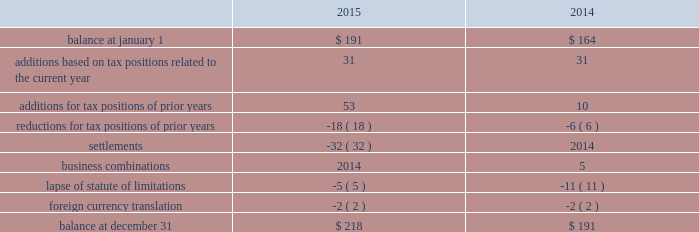Uncertain tax positions the following is a reconciliation of the company's beginning and ending amount of uncertain tax positions ( in millions ) : .
The company's liability for uncertain tax positions as of december 31 , 2015 , 2014 , and 2013 , includes $ 180 million , $ 154 million , and $ 141 million , respectively , related to amounts that would impact the effective tax rate if recognized .
It is possible that the amount of unrecognized tax benefits may change in the next twelve months ; however , we do not expect the change to have a significant impact on our consolidated statements of income or consolidated balance sheets .
These changes may be the result of settlements of ongoing audits .
At this time , an estimate of the range of the reasonably possible outcomes within the twelve months cannot be made .
The company recognizes interest and penalties related to uncertain tax positions in its provision for income taxes .
The company accrued potential interest and penalties of $ 2 million , $ 4 million , and $ 2 million in 2015 , 2014 , and 2013 , respectively .
The company recorded a liability for interest and penalties of $ 33 million , $ 31 million , and $ 27 million as of december 31 , 2015 , 2014 , and 2013 , respectively .
The company and its subsidiaries file income tax returns in their respective jurisdictions .
The company has substantially concluded all u.s .
Federal income tax matters for years through 2007 .
Material u.s .
State and local income tax jurisdiction examinations have been concluded for years through 2005 .
The company has concluded income tax examinations in its primary non-u.s .
Jurisdictions through 2005 .
Shareholders' equity distributable reserves as a u.k .
Incorporated company , the company is required under u.k .
Law to have available "distributable reserves" to make share repurchases or pay dividends to shareholders .
Distributable reserves may be created through the earnings of the u.k .
Parent company and , amongst other methods , through a reduction in share capital approved by the english companies court .
Distributable reserves are not linked to a u.s .
Gaap reported amount ( e.g. , retained earnings ) .
As of december 31 , 2015 and 2014 , the company had distributable reserves in excess of $ 2.1 billion and $ 4.0 billion , respectively .
Ordinary shares in april 2012 , the company's board of directors authorized a share repurchase program under which up to $ 5.0 billion of class a ordinary shares may be repurchased ( "2012 share repurchase program" ) .
In november 2014 , the company's board of directors authorized a new $ 5.0 billion share repurchase program in addition to the existing program ( "2014 share repurchase program" and , together , the "repurchase programs" ) .
Under each program , shares may be repurchased through the open market or in privately negotiated transactions , based on prevailing market conditions , funded from available capital .
During 2015 , the company repurchased 16.0 million shares at an average price per share of $ 97.04 for a total cost of $ 1.6 billion under the repurchase programs .
During 2014 , the company repurchased 25.8 million shares at an average price per share of $ 87.18 for a total cost of $ 2.3 billion under the 2012 share repurchase plan .
In august 2015 , the $ 5 billion of class a ordinary shares authorized under the 2012 share repurchase program was exhausted .
At december 31 , 2015 , the remaining authorized amount for share repurchase under the 2014 share repurchase program is $ 4.1 billion .
Under the repurchase programs , the company repurchased a total of 78.1 million shares for an aggregate cost of $ 5.9 billion. .
What is the net amount of uncertain tax positions for 2015 , ( in millions )? 
Computations: (218 - 191)
Answer: 27.0. 